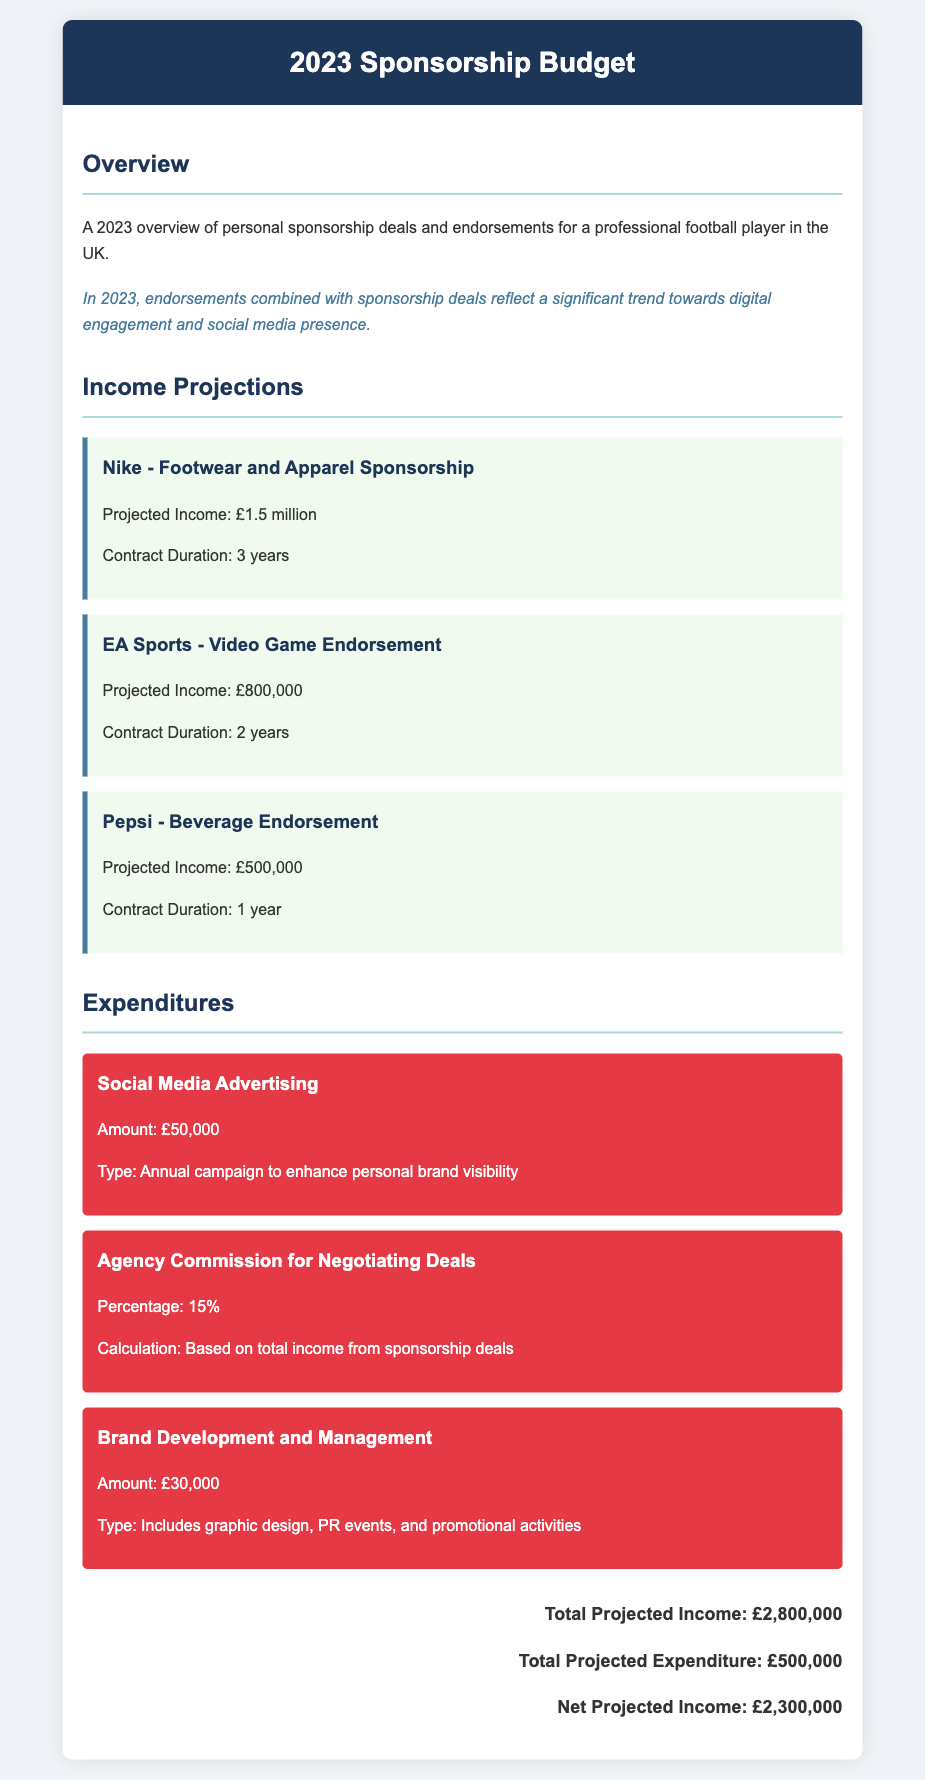What is the total projected income? The total projected income is calculated by summing up all projected incomes from individual sponsorship deals listed in the document.
Answer: £2,800,000 What is the projected income from Nike? The document specifies the projected income from the Nike sponsorship deal, which is noted in the income projections section.
Answer: £1.5 million What percentage is the agency commission for negotiating deals? The agency commission percentage is provided in the expenditures section as part of the expenses.
Answer: 15% What is the amount allocated for social media advertising? The amount for social media advertising is explicitly mentioned in the expenditures section.
Answer: £50,000 What is the projected income from Pepsi? The projected income from Pepsi is listed under the income projections section.
Answer: £500,000 What is the total projected expenditure? The total projected expenditure is the sum of all expenditures detailed in the document.
Answer: £500,000 What is the net projected income for 2023? The net projected income is derived from subtracting the total projected expenditure from the total projected income.
Answer: £2,300,000 What type of campaign is funded by the social media advertising budget? The document specifies the purpose of the social media advertising budget, which enhances personal brand visibility.
Answer: Annual campaign What does the brand development and management expenditure include? The document includes a brief description of what is covered under brand development and management expenditure.
Answer: Graphic design, PR events, and promotional activities 